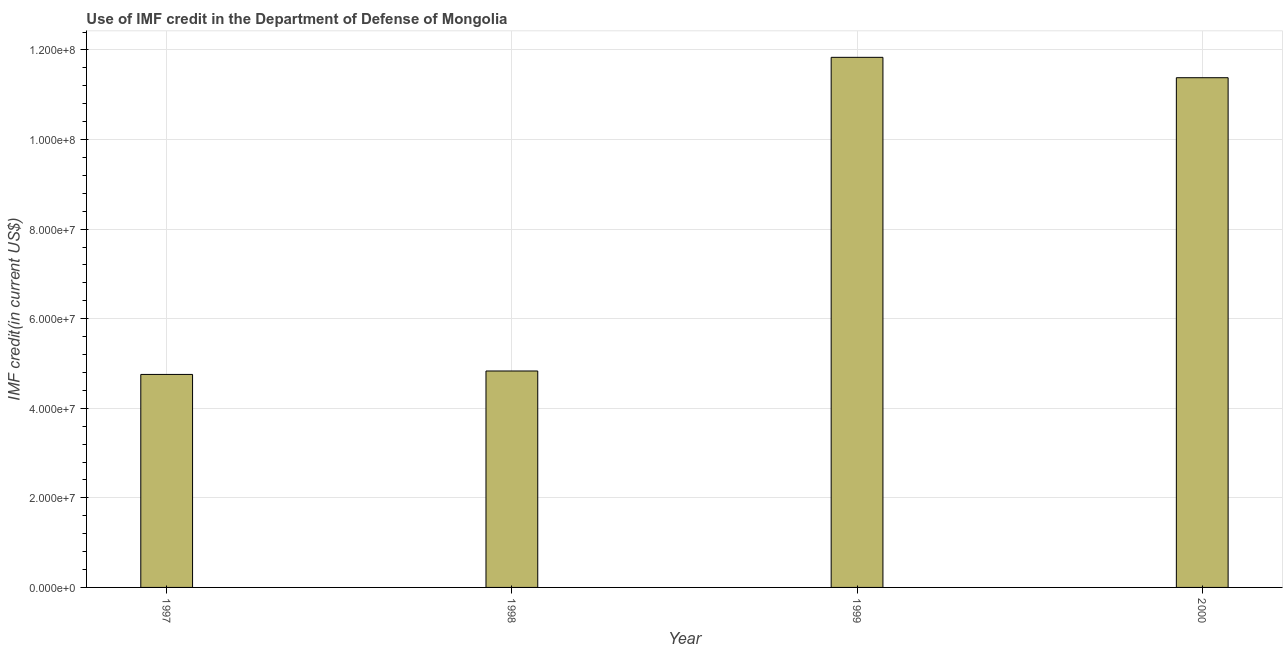Does the graph contain any zero values?
Keep it short and to the point. No. Does the graph contain grids?
Provide a short and direct response. Yes. What is the title of the graph?
Offer a very short reply. Use of IMF credit in the Department of Defense of Mongolia. What is the label or title of the Y-axis?
Offer a terse response. IMF credit(in current US$). What is the use of imf credit in dod in 2000?
Make the answer very short. 1.14e+08. Across all years, what is the maximum use of imf credit in dod?
Provide a succinct answer. 1.18e+08. Across all years, what is the minimum use of imf credit in dod?
Keep it short and to the point. 4.76e+07. What is the sum of the use of imf credit in dod?
Your answer should be compact. 3.28e+08. What is the difference between the use of imf credit in dod in 1999 and 2000?
Ensure brevity in your answer.  4.55e+06. What is the average use of imf credit in dod per year?
Your answer should be compact. 8.20e+07. What is the median use of imf credit in dod?
Provide a short and direct response. 8.11e+07. Do a majority of the years between 1999 and 1998 (inclusive) have use of imf credit in dod greater than 44000000 US$?
Ensure brevity in your answer.  No. What is the ratio of the use of imf credit in dod in 1999 to that in 2000?
Offer a terse response. 1.04. Is the difference between the use of imf credit in dod in 1997 and 2000 greater than the difference between any two years?
Make the answer very short. No. What is the difference between the highest and the second highest use of imf credit in dod?
Your response must be concise. 4.55e+06. Is the sum of the use of imf credit in dod in 1999 and 2000 greater than the maximum use of imf credit in dod across all years?
Keep it short and to the point. Yes. What is the difference between the highest and the lowest use of imf credit in dod?
Your answer should be very brief. 7.08e+07. In how many years, is the use of imf credit in dod greater than the average use of imf credit in dod taken over all years?
Give a very brief answer. 2. How many bars are there?
Keep it short and to the point. 4. How many years are there in the graph?
Your response must be concise. 4. What is the IMF credit(in current US$) of 1997?
Provide a short and direct response. 4.76e+07. What is the IMF credit(in current US$) in 1998?
Offer a very short reply. 4.83e+07. What is the IMF credit(in current US$) in 1999?
Provide a short and direct response. 1.18e+08. What is the IMF credit(in current US$) of 2000?
Offer a very short reply. 1.14e+08. What is the difference between the IMF credit(in current US$) in 1997 and 1998?
Provide a succinct answer. -7.68e+05. What is the difference between the IMF credit(in current US$) in 1997 and 1999?
Your response must be concise. -7.08e+07. What is the difference between the IMF credit(in current US$) in 1997 and 2000?
Give a very brief answer. -6.62e+07. What is the difference between the IMF credit(in current US$) in 1998 and 1999?
Your response must be concise. -7.00e+07. What is the difference between the IMF credit(in current US$) in 1998 and 2000?
Offer a very short reply. -6.55e+07. What is the difference between the IMF credit(in current US$) in 1999 and 2000?
Ensure brevity in your answer.  4.55e+06. What is the ratio of the IMF credit(in current US$) in 1997 to that in 1999?
Keep it short and to the point. 0.4. What is the ratio of the IMF credit(in current US$) in 1997 to that in 2000?
Make the answer very short. 0.42. What is the ratio of the IMF credit(in current US$) in 1998 to that in 1999?
Offer a terse response. 0.41. What is the ratio of the IMF credit(in current US$) in 1998 to that in 2000?
Your answer should be compact. 0.42. What is the ratio of the IMF credit(in current US$) in 1999 to that in 2000?
Provide a succinct answer. 1.04. 